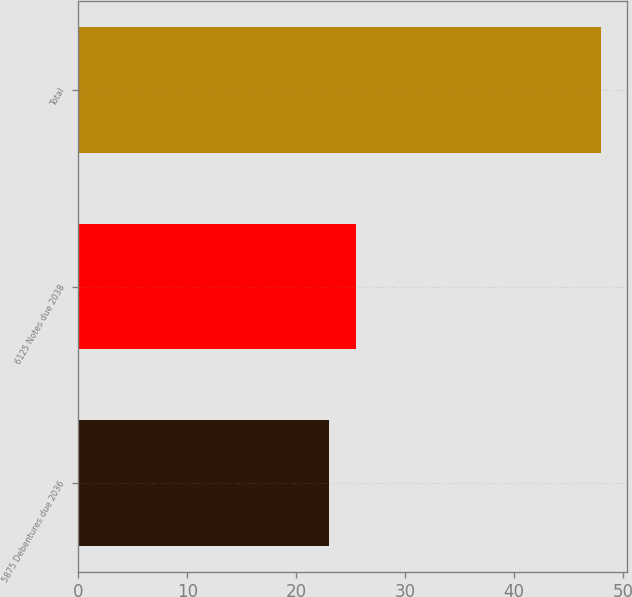Convert chart. <chart><loc_0><loc_0><loc_500><loc_500><bar_chart><fcel>5875 Debentures due 2036<fcel>6125 Notes due 2038<fcel>Total<nl><fcel>23<fcel>25.5<fcel>48<nl></chart> 